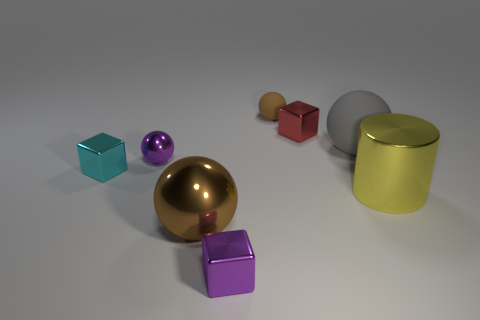Subtract all tiny purple spheres. How many spheres are left? 3 Subtract all brown spheres. How many spheres are left? 2 Subtract all cylinders. How many objects are left? 7 Add 1 large yellow shiny objects. How many objects exist? 9 Subtract 0 gray cubes. How many objects are left? 8 Subtract 1 blocks. How many blocks are left? 2 Subtract all purple cylinders. Subtract all green spheres. How many cylinders are left? 1 Subtract all cyan cylinders. How many purple cubes are left? 1 Subtract all spheres. Subtract all cyan matte blocks. How many objects are left? 4 Add 7 small brown spheres. How many small brown spheres are left? 8 